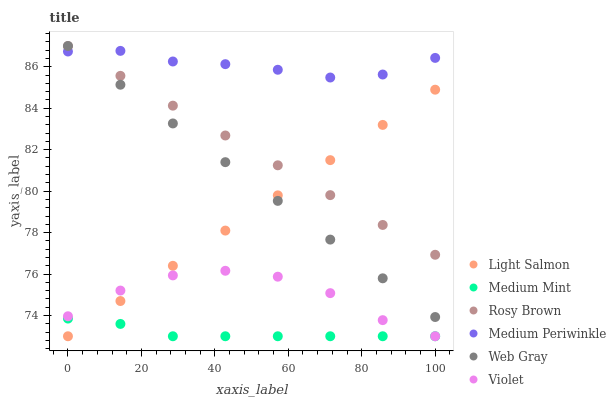Does Medium Mint have the minimum area under the curve?
Answer yes or no. Yes. Does Medium Periwinkle have the maximum area under the curve?
Answer yes or no. Yes. Does Light Salmon have the minimum area under the curve?
Answer yes or no. No. Does Light Salmon have the maximum area under the curve?
Answer yes or no. No. Is Light Salmon the smoothest?
Answer yes or no. Yes. Is Violet the roughest?
Answer yes or no. Yes. Is Web Gray the smoothest?
Answer yes or no. No. Is Web Gray the roughest?
Answer yes or no. No. Does Medium Mint have the lowest value?
Answer yes or no. Yes. Does Web Gray have the lowest value?
Answer yes or no. No. Does Rosy Brown have the highest value?
Answer yes or no. Yes. Does Light Salmon have the highest value?
Answer yes or no. No. Is Medium Mint less than Medium Periwinkle?
Answer yes or no. Yes. Is Medium Periwinkle greater than Violet?
Answer yes or no. Yes. Does Medium Periwinkle intersect Web Gray?
Answer yes or no. Yes. Is Medium Periwinkle less than Web Gray?
Answer yes or no. No. Is Medium Periwinkle greater than Web Gray?
Answer yes or no. No. Does Medium Mint intersect Medium Periwinkle?
Answer yes or no. No. 